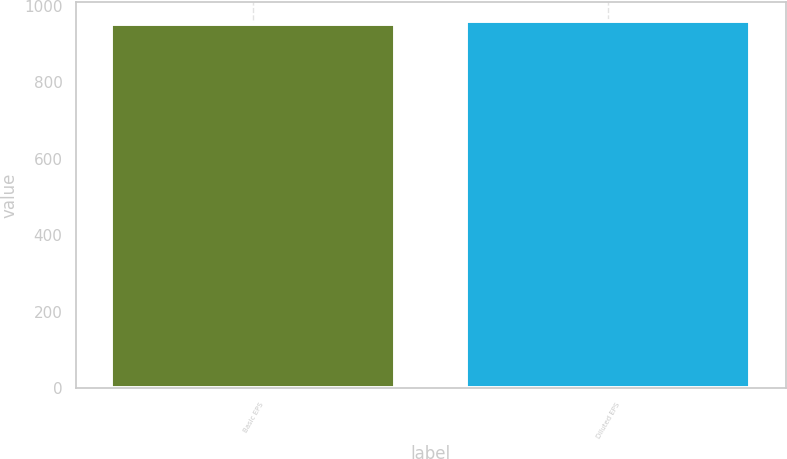Convert chart. <chart><loc_0><loc_0><loc_500><loc_500><bar_chart><fcel>Basic EPS<fcel>Diluted EPS<nl><fcel>952.1<fcel>960.2<nl></chart> 